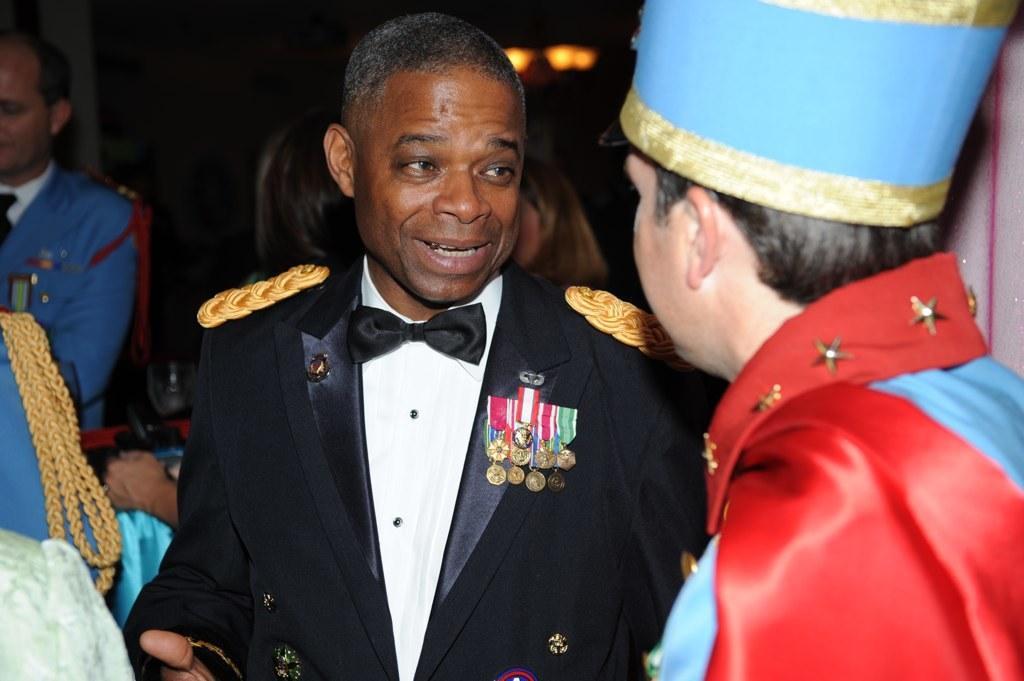How would you summarize this image in a sentence or two? The man in the middle of the picture wearing a white shirt and black blazer is talking to the man beside him who is wearing red and blue shirt. On the left corner of the picture, we see the man wearing the blue blazer is sitting on the chair. In the background, it is black in color. 